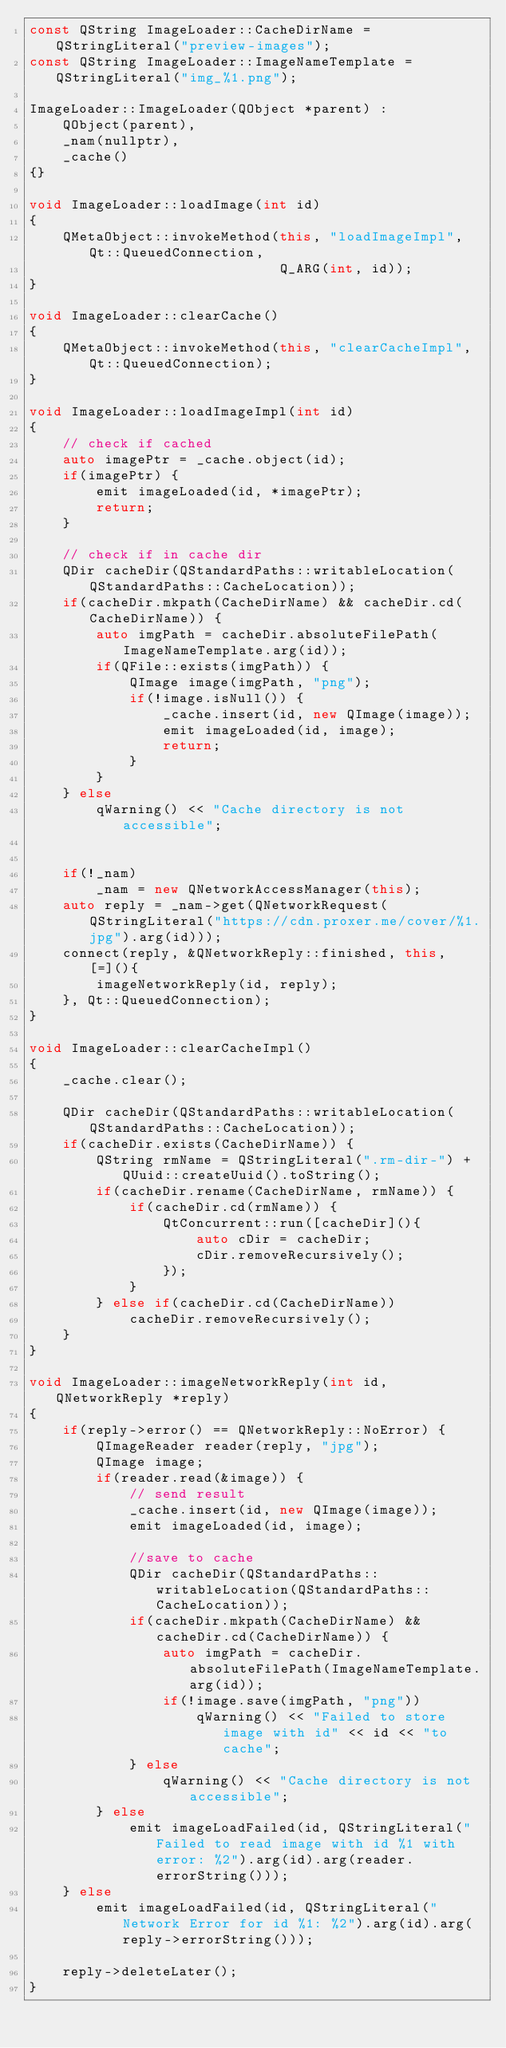Convert code to text. <code><loc_0><loc_0><loc_500><loc_500><_C++_>const QString ImageLoader::CacheDirName = QStringLiteral("preview-images");
const QString ImageLoader::ImageNameTemplate = QStringLiteral("img_%1.png");

ImageLoader::ImageLoader(QObject *parent) :
	QObject(parent),
	_nam(nullptr),
	_cache()
{}

void ImageLoader::loadImage(int id)
{
	QMetaObject::invokeMethod(this, "loadImageImpl", Qt::QueuedConnection,
							  Q_ARG(int, id));
}

void ImageLoader::clearCache()
{
	QMetaObject::invokeMethod(this, "clearCacheImpl", Qt::QueuedConnection);
}

void ImageLoader::loadImageImpl(int id)
{
	// check if cached
	auto imagePtr = _cache.object(id);
	if(imagePtr) {
		emit imageLoaded(id, *imagePtr);
		return;
	}

	// check if in cache dir
	QDir cacheDir(QStandardPaths::writableLocation(QStandardPaths::CacheLocation));
	if(cacheDir.mkpath(CacheDirName) && cacheDir.cd(CacheDirName)) {
		auto imgPath = cacheDir.absoluteFilePath(ImageNameTemplate.arg(id));
		if(QFile::exists(imgPath)) {
			QImage image(imgPath, "png");
			if(!image.isNull()) {
				_cache.insert(id, new QImage(image));
				emit imageLoaded(id, image);
				return;
			}
		}
	} else
		qWarning() << "Cache directory is not accessible";


	if(!_nam)
		_nam = new QNetworkAccessManager(this);
	auto reply = _nam->get(QNetworkRequest(QStringLiteral("https://cdn.proxer.me/cover/%1.jpg").arg(id)));
	connect(reply, &QNetworkReply::finished, this, [=](){
		imageNetworkReply(id, reply);
	}, Qt::QueuedConnection);
}

void ImageLoader::clearCacheImpl()
{
	_cache.clear();

	QDir cacheDir(QStandardPaths::writableLocation(QStandardPaths::CacheLocation));
	if(cacheDir.exists(CacheDirName)) {
		QString rmName = QStringLiteral(".rm-dir-") + QUuid::createUuid().toString();
		if(cacheDir.rename(CacheDirName, rmName)) {
			if(cacheDir.cd(rmName)) {
				QtConcurrent::run([cacheDir](){
					auto cDir = cacheDir;
					cDir.removeRecursively();
				});
			}
		} else if(cacheDir.cd(CacheDirName))
			cacheDir.removeRecursively();
	}
}

void ImageLoader::imageNetworkReply(int id, QNetworkReply *reply)
{
	if(reply->error() == QNetworkReply::NoError) {
		QImageReader reader(reply, "jpg");
		QImage image;
		if(reader.read(&image)) {
			// send result
			_cache.insert(id, new QImage(image));
			emit imageLoaded(id, image);

			//save to cache
			QDir cacheDir(QStandardPaths::writableLocation(QStandardPaths::CacheLocation));
			if(cacheDir.mkpath(CacheDirName) && cacheDir.cd(CacheDirName)) {
				auto imgPath = cacheDir.absoluteFilePath(ImageNameTemplate.arg(id));
				if(!image.save(imgPath, "png"))
					qWarning() << "Failed to store image with id" << id << "to cache";
			} else
				qWarning() << "Cache directory is not accessible";
		} else
			emit imageLoadFailed(id, QStringLiteral("Failed to read image with id %1 with error: %2").arg(id).arg(reader.errorString()));
	} else
		emit imageLoadFailed(id, QStringLiteral("Network Error for id %1: %2").arg(id).arg(reply->errorString()));

	reply->deleteLater();
}
</code> 